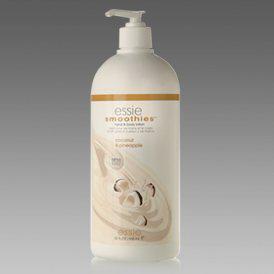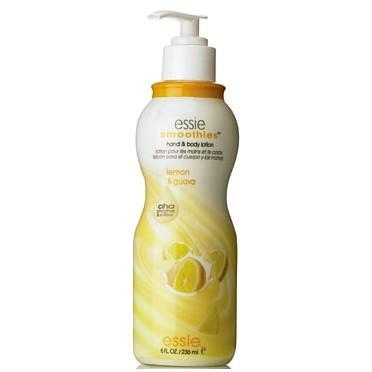The first image is the image on the left, the second image is the image on the right. Given the left and right images, does the statement "The left and right image contains the same number of soaps and lotions." hold true? Answer yes or no. Yes. The first image is the image on the left, the second image is the image on the right. Evaluate the accuracy of this statement regarding the images: "All skincare items shown have pump dispensers, and at least one image contains only one skincare item.". Is it true? Answer yes or no. Yes. 